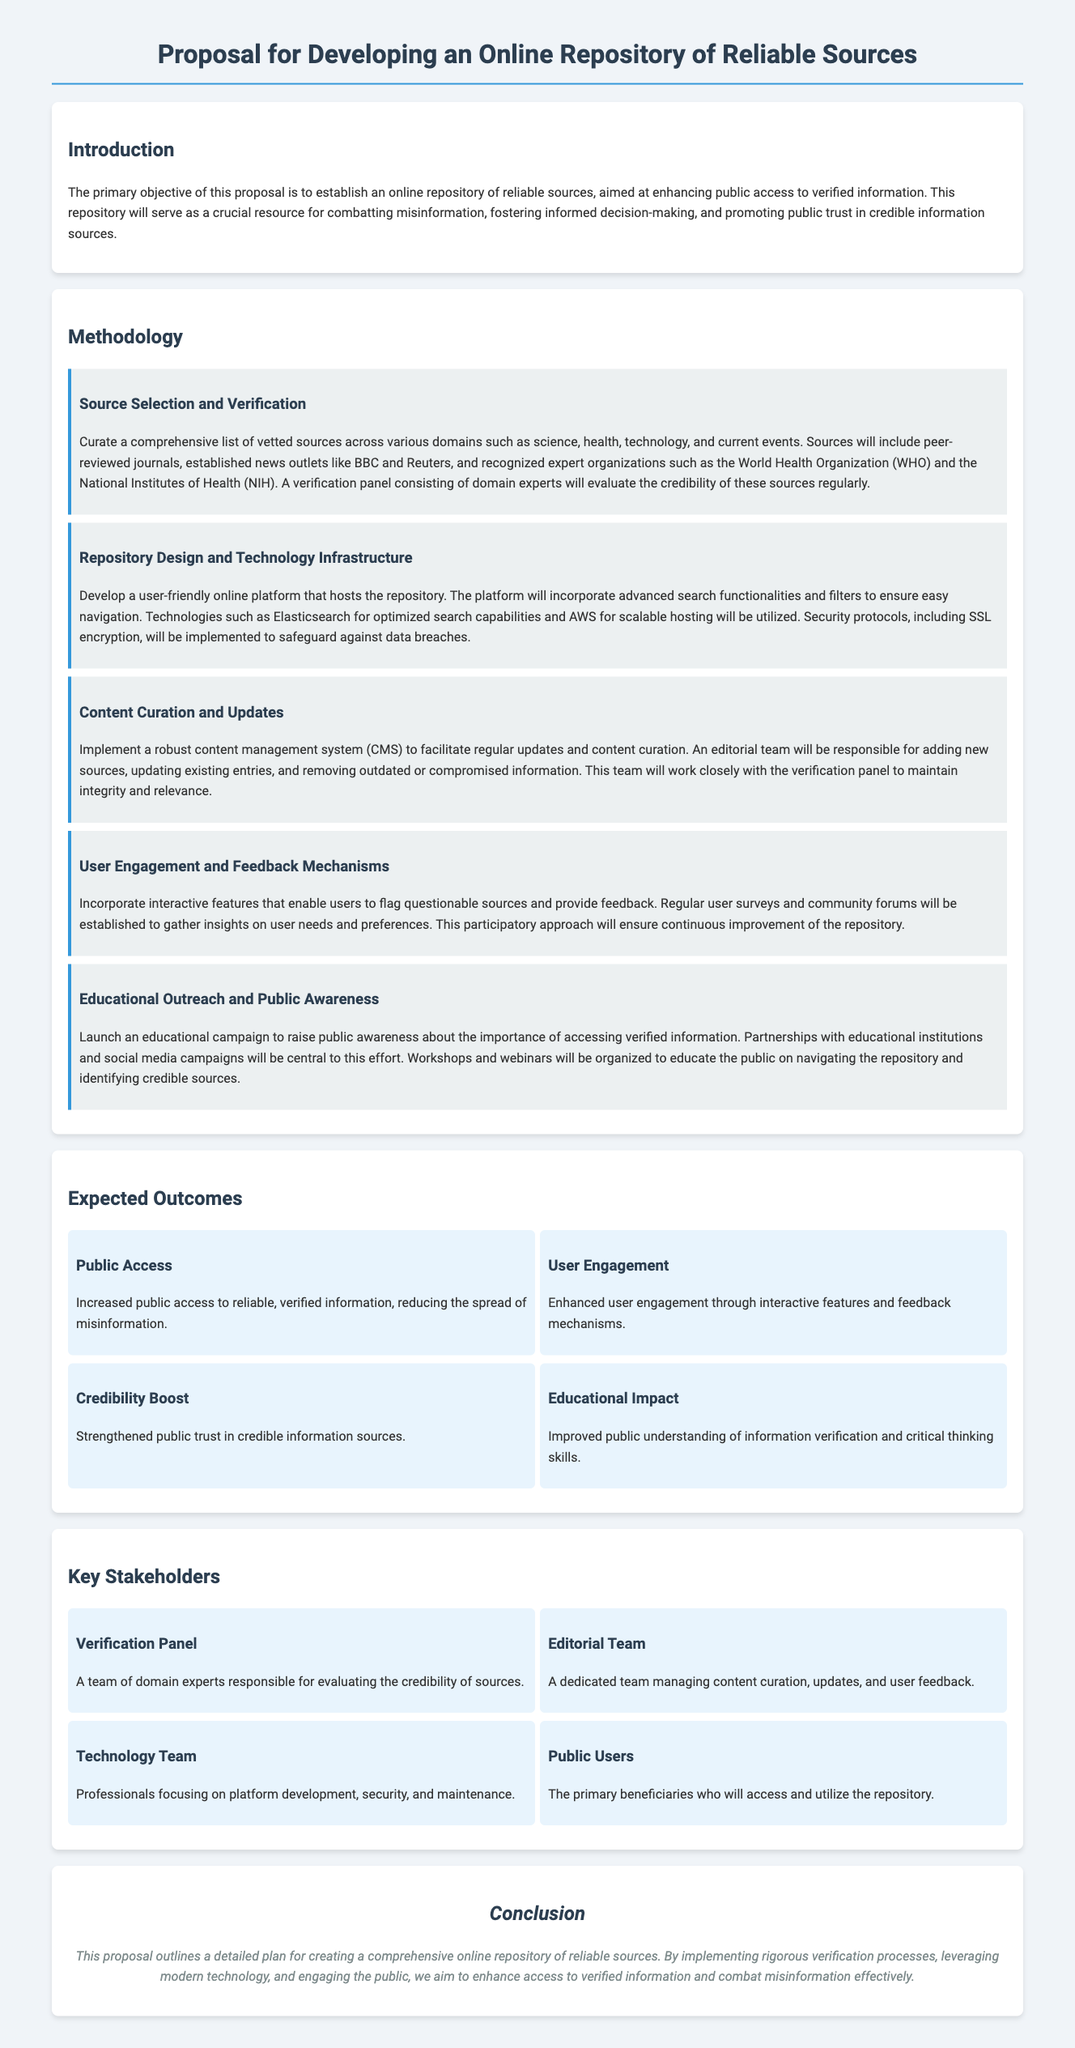What is the primary objective of the proposal? The primary objective outlined in the document is to establish an online repository of reliable sources.
Answer: Establish an online repository of reliable sources Which organizations are mentioned as reliable sources? The document lists organizations like the World Health Organization and the National Institutes of Health as part of the reliable sources.
Answer: World Health Organization and National Institutes of Health What technology will be used for the repository's infrastructure? The document mentions using AWS for scalable hosting and Elasticsearch for optimized search capabilities.
Answer: AWS and Elasticsearch Who will be responsible for evaluating the credibility of sources? A verification panel consisting of domain experts will be responsible for evaluating the credibility of the sources.
Answer: Verification panel What type of engagement method is proposed for user feedback? The document states that regular user surveys and community forums will be established to gather insights on user needs and preferences.
Answer: Regular user surveys and community forums How many expected outcomes are listed in the document? There are four expected outcomes listed in the proposal.
Answer: Four Who are the primary beneficiaries of the repository? The primary beneficiaries identified in the document are public users who will access and utilize the repository.
Answer: Public users What is mentioned as part of the educational outreach? The proposal mentions that workshops and webinars will be organized as part of the educational outreach.
Answer: Workshops and webinars What is the role of the editorial team? The editorial team's role is to manage content curation, updates, and user feedback within the repository.
Answer: Manage content curation, updates, and user feedback 